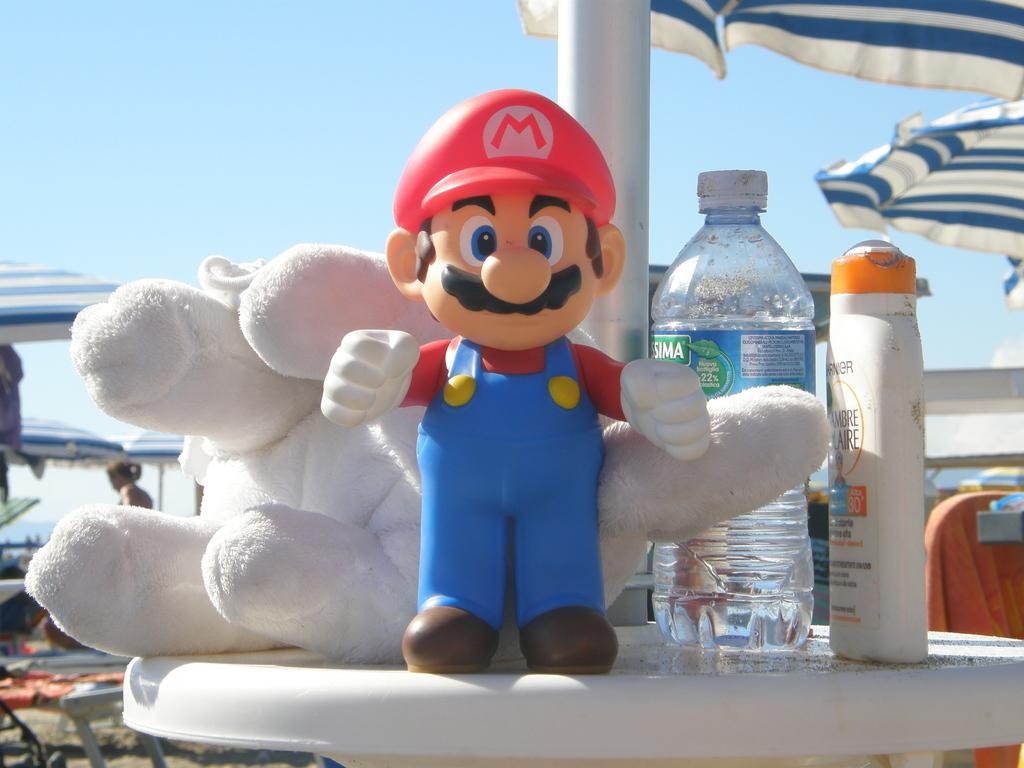What type of object is on the table in the image? There is a cartoon toy on the table. What else can be seen on the table? There are bottles on the table. What additional items are present in the image? There are umbrellas in the image. Can you describe the person in the image? A person is standing far away. What is the color of the sky in the image? The sky is blue. What type of island can be seen in the image? There is no island present in the image. 